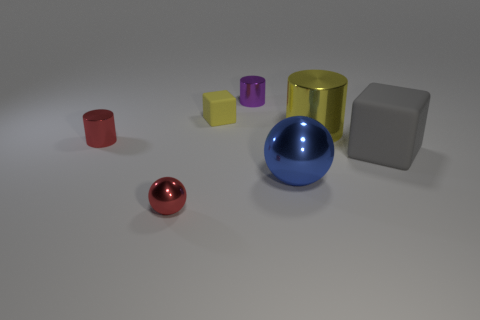Subtract all small cylinders. How many cylinders are left? 1 Subtract 1 cylinders. How many cylinders are left? 2 Add 2 tiny gray matte cylinders. How many objects exist? 9 Subtract all cylinders. How many objects are left? 4 Add 2 large blocks. How many large blocks exist? 3 Subtract 0 brown balls. How many objects are left? 7 Subtract all yellow metallic cylinders. Subtract all metallic things. How many objects are left? 1 Add 6 red spheres. How many red spheres are left? 7 